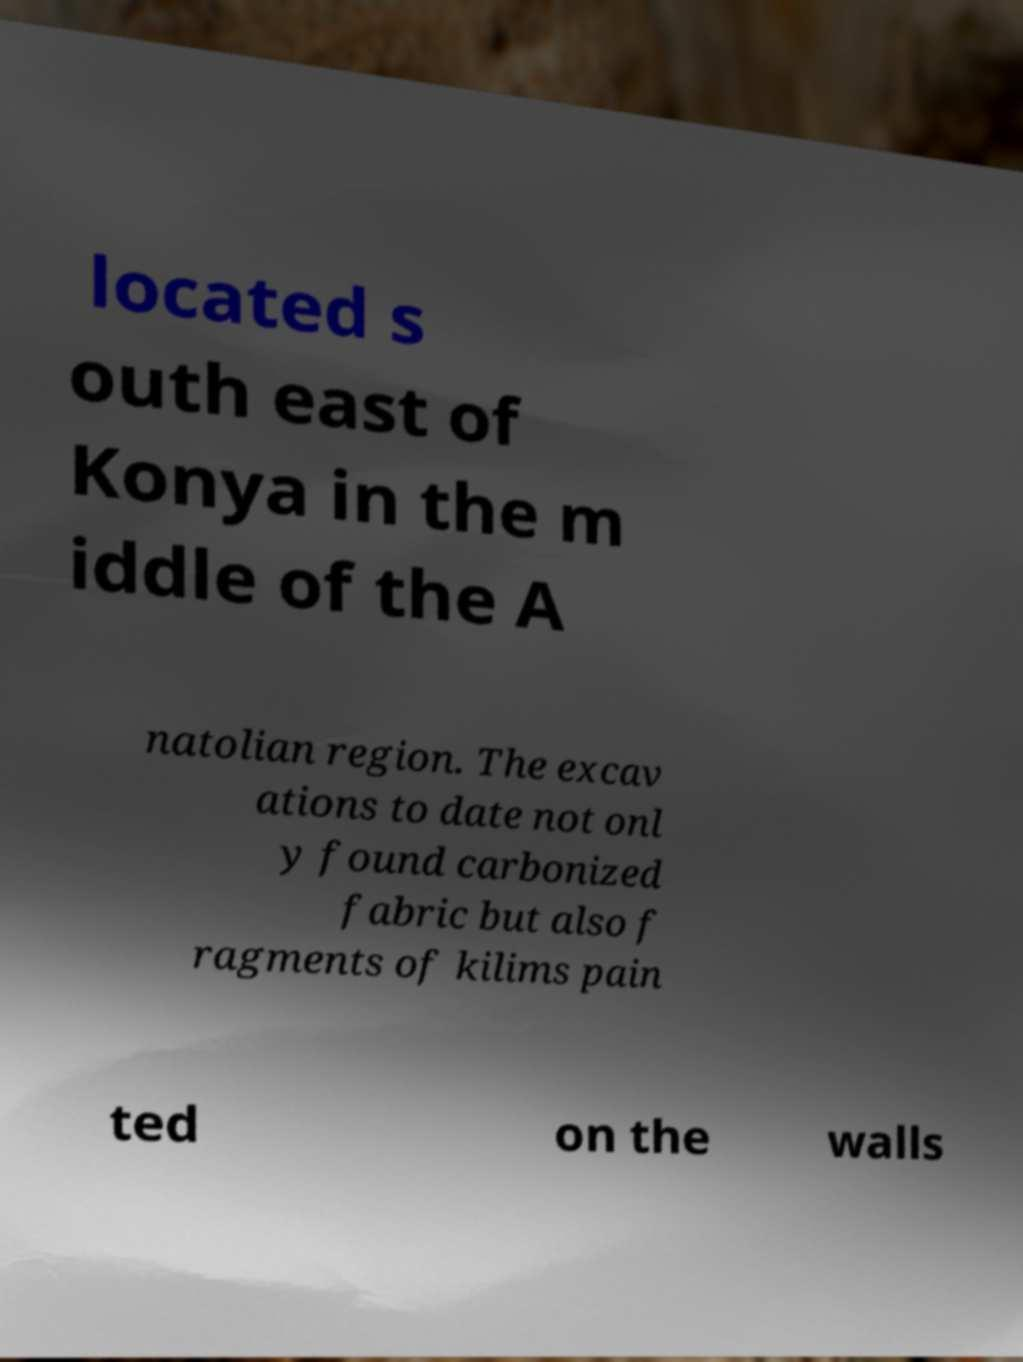Can you accurately transcribe the text from the provided image for me? located s outh east of Konya in the m iddle of the A natolian region. The excav ations to date not onl y found carbonized fabric but also f ragments of kilims pain ted on the walls 